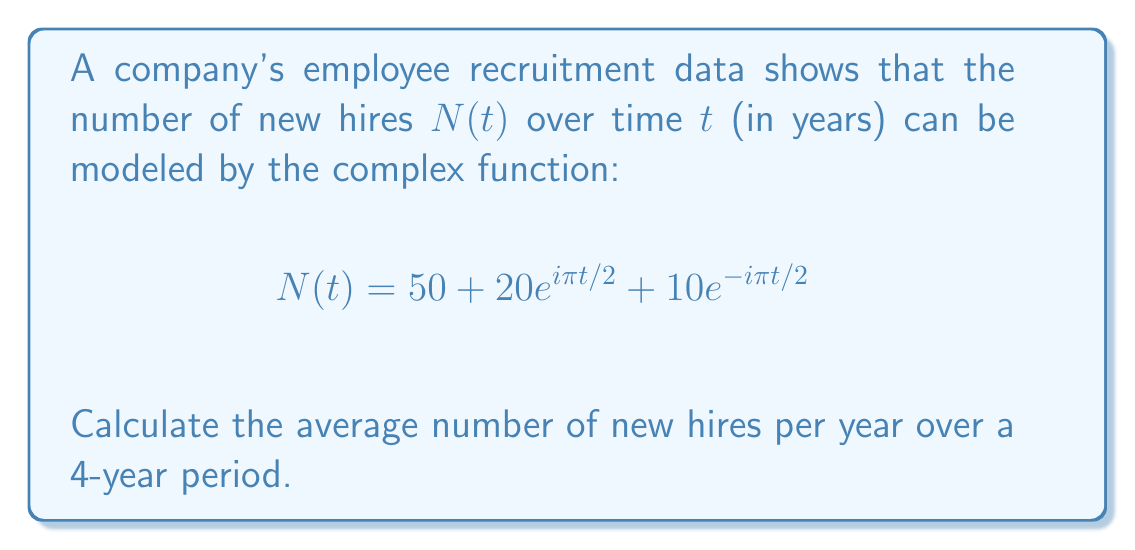What is the answer to this math problem? To solve this problem, we need to follow these steps:

1) First, we need to understand what the given function represents. The function $N(t)$ is a complex-valued function that models the number of new hires over time. It consists of a constant term and two complex exponential terms.

2) To find the average number of new hires over a 4-year period, we need to integrate the real part of this function over the interval $[0,4]$ and then divide by 4.

3) Let's separate the real and imaginary parts of the function:

   $$N(t) = 50 + 20(\cos(\pi t/2) + i\sin(\pi t/2)) + 10(\cos(-\pi t/2) + i\sin(-\pi t/2))$$
   $$= 50 + 20\cos(\pi t/2) + i20\sin(\pi t/2) + 10\cos(\pi t/2) - i10\sin(\pi t/2)$$
   $$= 50 + 30\cos(\pi t/2) + i10\sin(\pi t/2)$$

4) The real part of $N(t)$ is:

   $$\text{Re}(N(t)) = 50 + 30\cos(\pi t/2)$$

5) Now, we need to integrate this function from 0 to 4:

   $$\int_0^4 (50 + 30\cos(\pi t/2)) dt = 50t + \frac{60}{\pi/2}\sin(\pi t/2) \bigg|_0^4$$
   $$= (200 + \frac{60}{\pi/2}\sin(2\pi)) - (0 + \frac{60}{\pi/2}\sin(0))$$
   $$= 200 + 0 - 0 = 200$$

6) To get the average, we divide this result by 4:

   $$\frac{200}{4} = 50$$

Therefore, the average number of new hires per year over a 4-year period is 50.
Answer: 50 new hires per year 